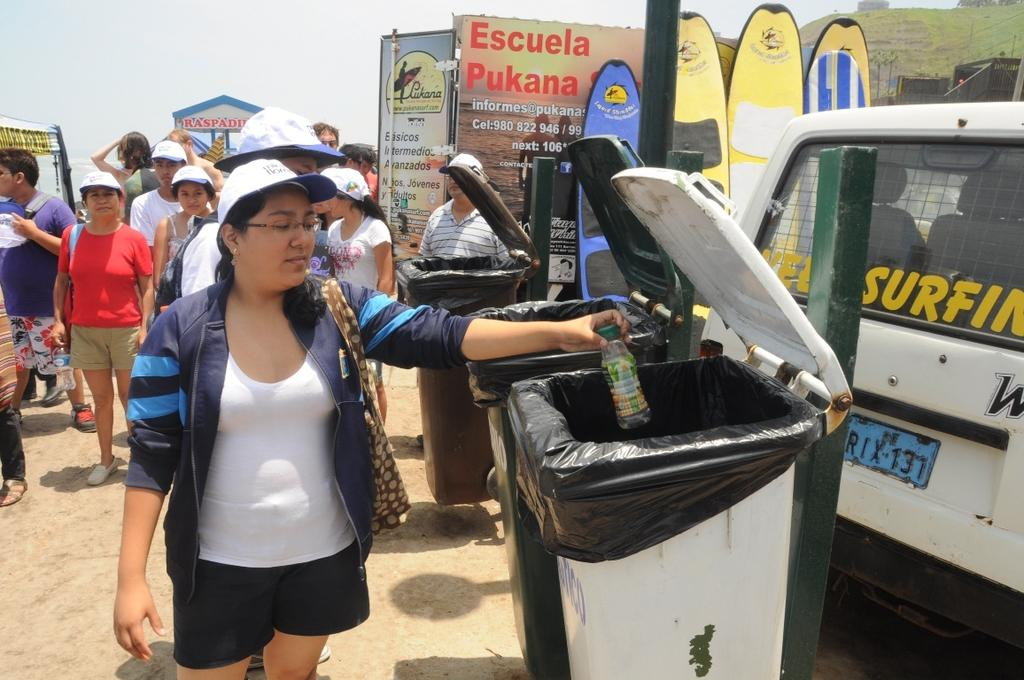<image>
Relay a brief, clear account of the picture shown. A woman throwing away a bottle at a Surfing event. 